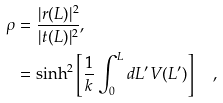<formula> <loc_0><loc_0><loc_500><loc_500>\rho & = \frac { | r ( L ) | ^ { 2 } } { | t ( L ) | ^ { 2 } } , \\ & = \sinh ^ { 2 } \left [ \frac { 1 } { k } \int ^ { L } _ { 0 } d L ^ { \prime } V ( L ^ { \prime } ) \right ] \quad ,</formula> 